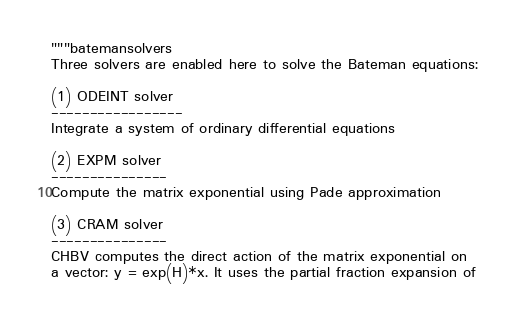<code> <loc_0><loc_0><loc_500><loc_500><_Python_>"""batemansolvers
Three solvers are enabled here to solve the Bateman equations:

(1) ODEINT solver
-----------------
Integrate a system of ordinary differential equations

(2) EXPM solver
---------------
Compute the matrix exponential using Pade approximation

(3) CRAM solver
---------------
CHBV computes the direct action of the matrix exponential on
a vector: y = exp(H)*x. It uses the partial fraction expansion of</code> 